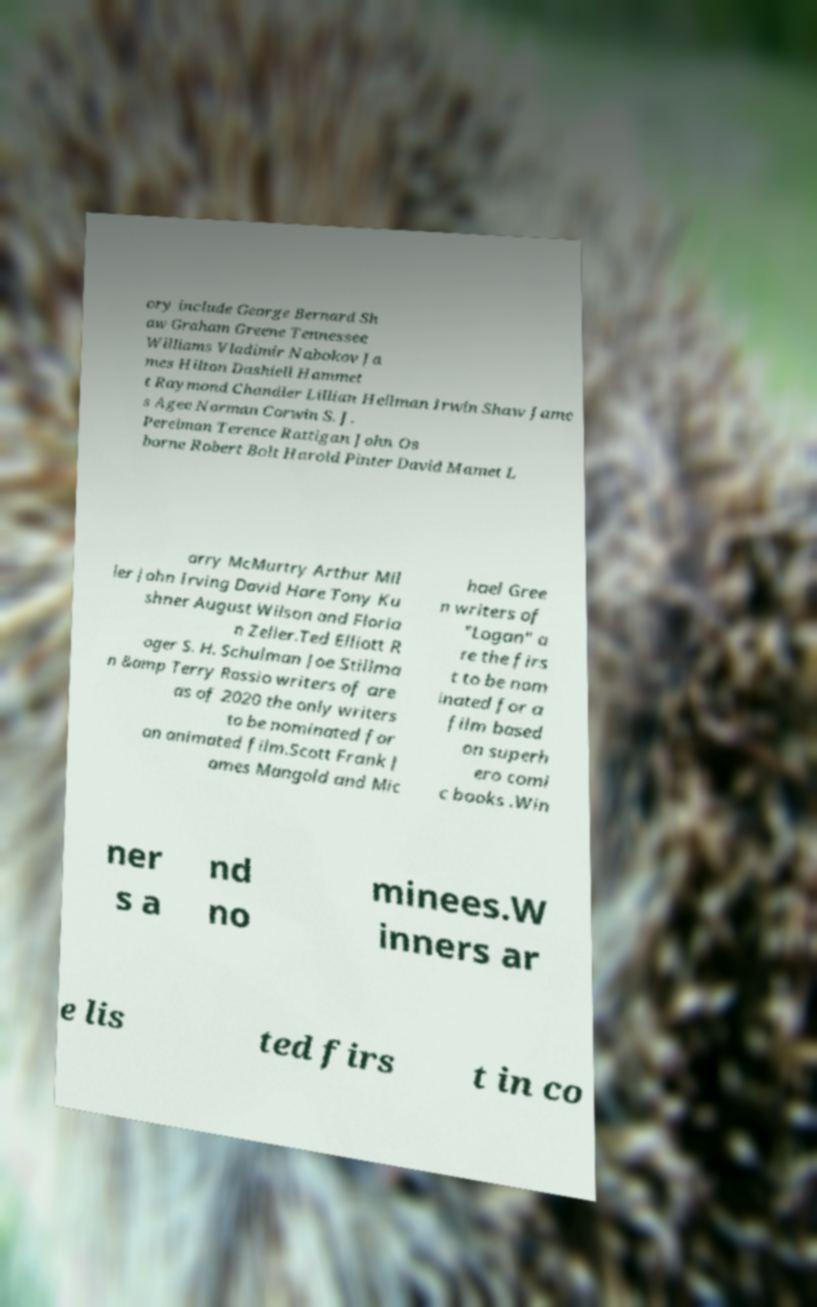I need the written content from this picture converted into text. Can you do that? ory include George Bernard Sh aw Graham Greene Tennessee Williams Vladimir Nabokov Ja mes Hilton Dashiell Hammet t Raymond Chandler Lillian Hellman Irwin Shaw Jame s Agee Norman Corwin S. J. Perelman Terence Rattigan John Os borne Robert Bolt Harold Pinter David Mamet L arry McMurtry Arthur Mil ler John Irving David Hare Tony Ku shner August Wilson and Floria n Zeller.Ted Elliott R oger S. H. Schulman Joe Stillma n &amp Terry Rossio writers of are as of 2020 the only writers to be nominated for an animated film.Scott Frank J ames Mangold and Mic hael Gree n writers of "Logan" a re the firs t to be nom inated for a film based on superh ero comi c books .Win ner s a nd no minees.W inners ar e lis ted firs t in co 